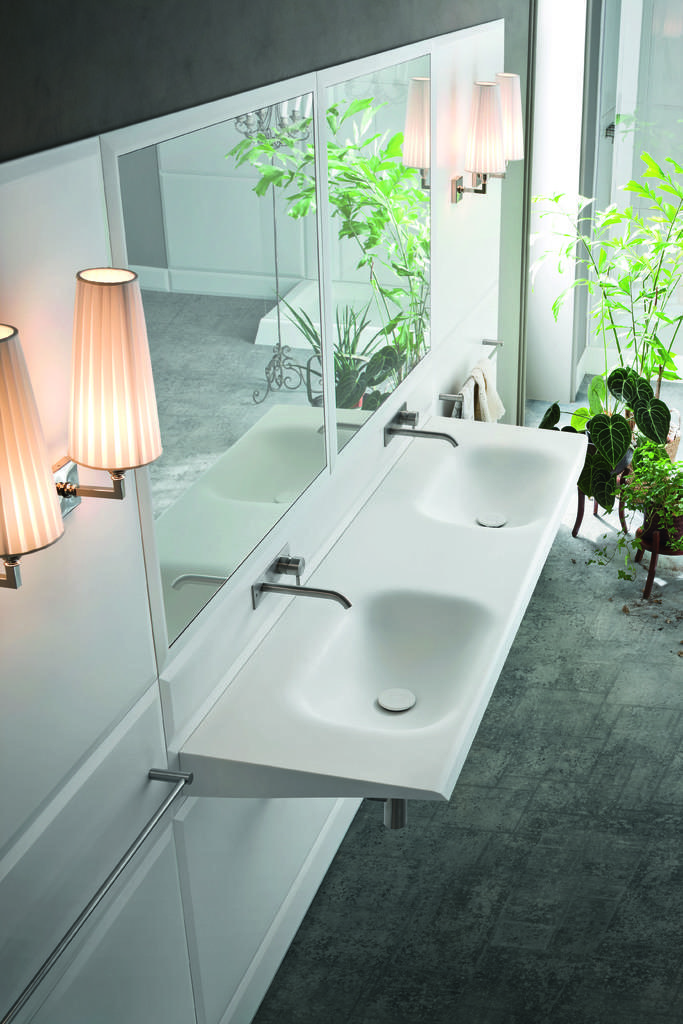How would you summarize this image in a sentence or two? In this image we can see the sinks with the taps. We can also see the mirrors and lamps on a wall, some plants in the pots and a towel on a holder. 